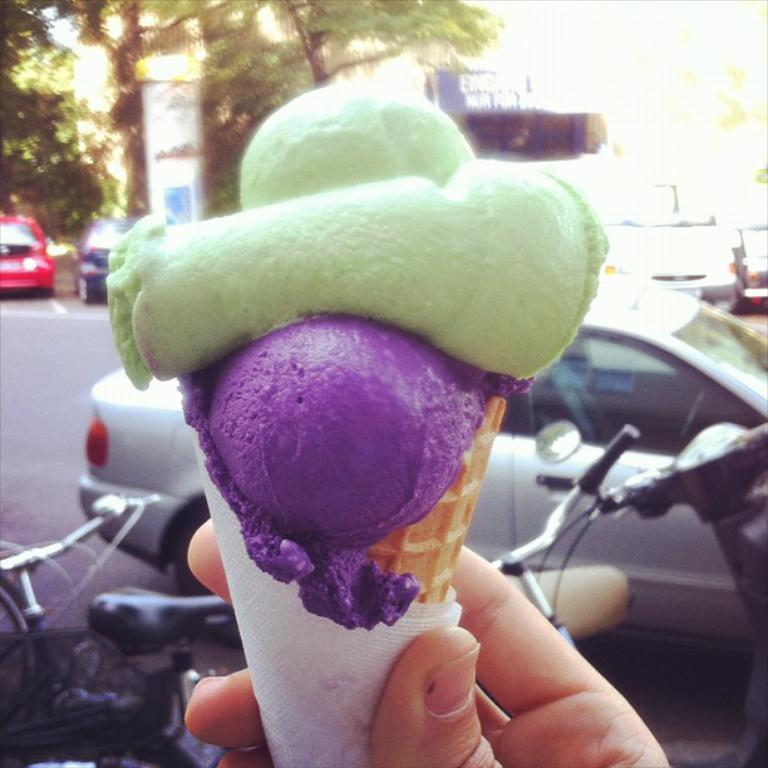What is the person holding in the image? The person is holding a cone ice cream and tissues at the bottom of the image. What can be seen in the middle of the image? There are cars, cycles, trees, buildings, and a road in the middle of the image. What type of root can be seen growing from the ice cream cone in the image? There is no root growing from the ice cream cone in the image. 